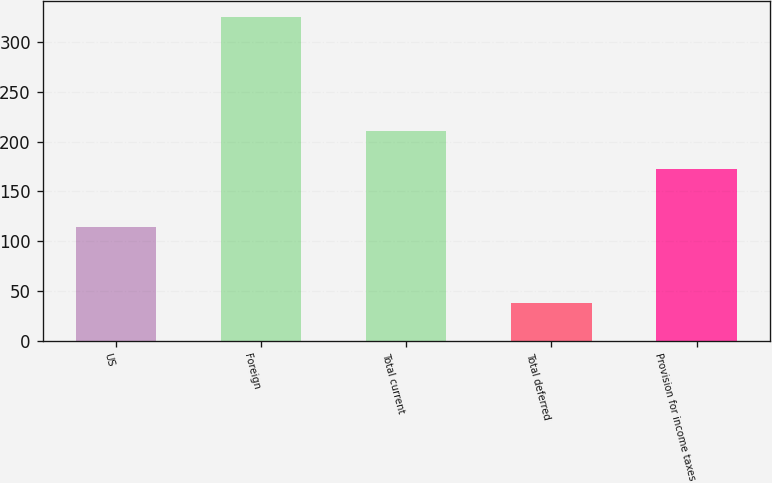Convert chart. <chart><loc_0><loc_0><loc_500><loc_500><bar_chart><fcel>US<fcel>Foreign<fcel>Total current<fcel>Total deferred<fcel>Provision for income taxes<nl><fcel>114<fcel>325<fcel>211<fcel>38<fcel>173<nl></chart> 